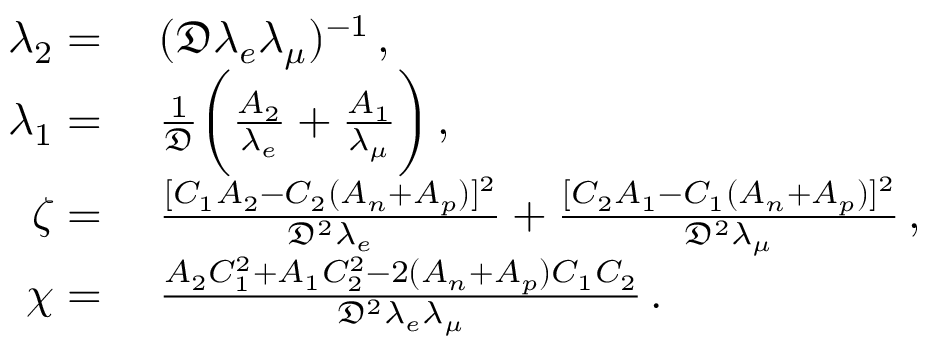<formula> <loc_0><loc_0><loc_500><loc_500>\begin{array} { r l } { \lambda _ { 2 } } & ( \mathfrak { D } \lambda _ { e } \lambda _ { \mu } ) ^ { - 1 } \, , } \\ { \lambda _ { 1 } } & \frac { 1 } { \mathfrak { D } } \left ( \frac { A _ { 2 } } { \lambda _ { e } } + \frac { A _ { 1 } } { \lambda _ { \mu } } \right ) \, , } \\ { \zeta } & \frac { [ C _ { 1 } A _ { 2 } - C _ { 2 } ( A _ { n } + A _ { p } ) ] ^ { 2 } } { \mathfrak { D } ^ { 2 } \lambda _ { e } } + \frac { [ C _ { 2 } A _ { 1 } - C _ { 1 } ( A _ { n } + A _ { p } ) ] ^ { 2 } } { \mathfrak { D } ^ { 2 } \lambda _ { \mu } } \, , } \\ { \chi } & \frac { A _ { 2 } C _ { 1 } ^ { 2 } + A _ { 1 } C _ { 2 } ^ { 2 } - 2 ( A _ { n } + A _ { p } ) C _ { 1 } C _ { 2 } } { \mathfrak { D } ^ { 2 } \lambda _ { e } \lambda _ { \mu } } \, . } \end{array}</formula> 